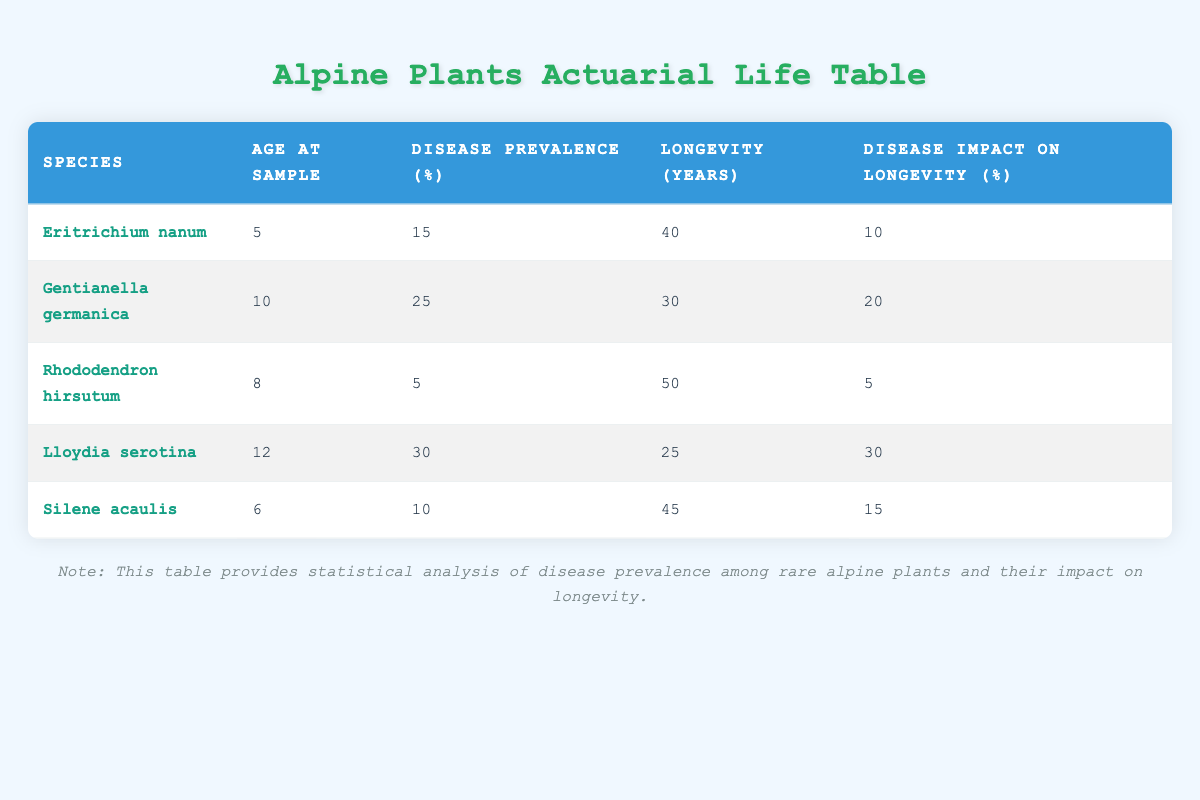What is the disease prevalence percentage of Gentianella germanica? The table explicitly shows that the disease prevalence percentage for Gentianella germanica is 25%.
Answer: 25% What is the species with the highest longevity? By examining the longevity years column, Rhododendron hirsutum has the highest value at 50 years.
Answer: Rhododendron hirsutum How does the disease impact longevity for Lloydia serotina? The table indicates that the disease impact on longevity for Lloydia serotina is 30%, meaning its overall longevity may be reduced by this percentage.
Answer: 30% What is the average age at sample of all the alpine plants listed? The ages at sample are 5, 10, 8, 12, and 6. Adding these gives 41, and dividing by 5 provides an average of 8.2.
Answer: 8.2 Is the disease prevalence for Silene acaulis greater than for Eritrichium nanum? The disease prevalence for Silene acaulis is 10%, while for Eritrichium nanum it is 15%, so 10% is not greater than 15%.
Answer: No Which species has the lowest disease impact on longevity percentage? Looking through the table, Rhododendron hirsutum has a disease impact on longevity percentage of 5%, which is the lowest compared to the other species.
Answer: Rhododendron hirsutum What is the total longevity of all plants listed in the table? Summing the longevity years of all species provides: 40 + 30 + 50 + 25 + 45 = 190 years total.
Answer: 190 Does the species with the highest disease prevalence also have the highest disease impact on longevity? Lloydia serotina has the highest disease prevalence at 30%, but its disease impact on longevity (30%) is equal, not highest; Gentianella germanica has a higher impact (20%).
Answer: No If the disease prevalence increases by 5% for each species, what would be the new prevalence percentage for Silene acaulis? Currently, Silene acaulis has a disease prevalence of 10%. If it increases by 5%, the new prevalence would be 10 + 5 = 15%.
Answer: 15% 